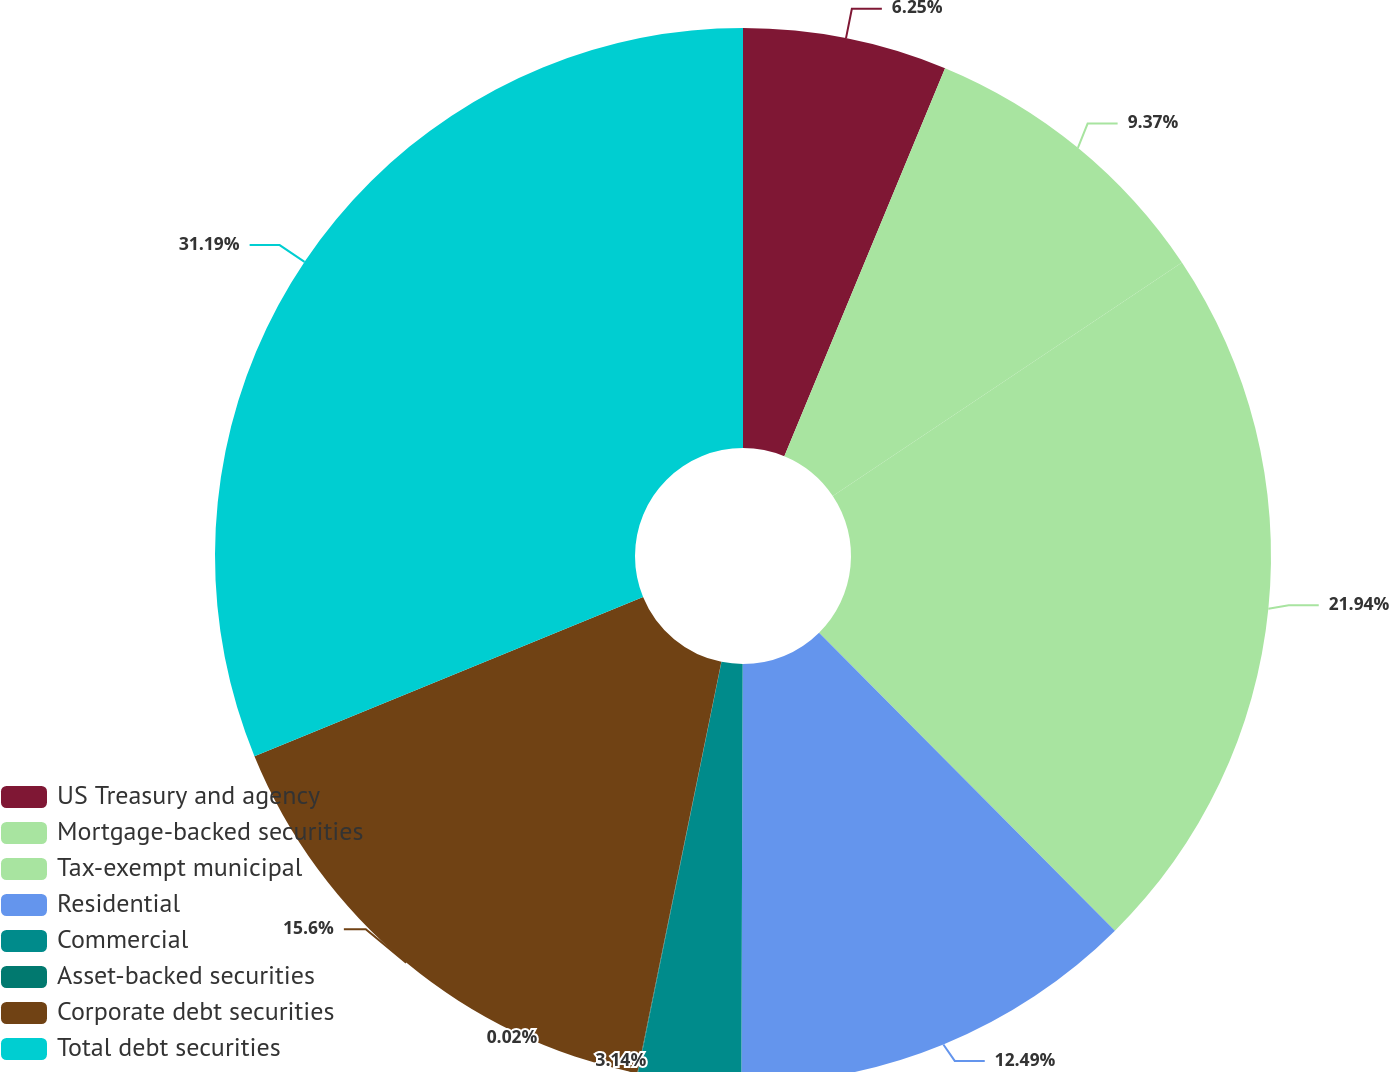Convert chart to OTSL. <chart><loc_0><loc_0><loc_500><loc_500><pie_chart><fcel>US Treasury and agency<fcel>Mortgage-backed securities<fcel>Tax-exempt municipal<fcel>Residential<fcel>Commercial<fcel>Asset-backed securities<fcel>Corporate debt securities<fcel>Total debt securities<nl><fcel>6.25%<fcel>9.37%<fcel>21.94%<fcel>12.49%<fcel>3.14%<fcel>0.02%<fcel>15.6%<fcel>31.19%<nl></chart> 